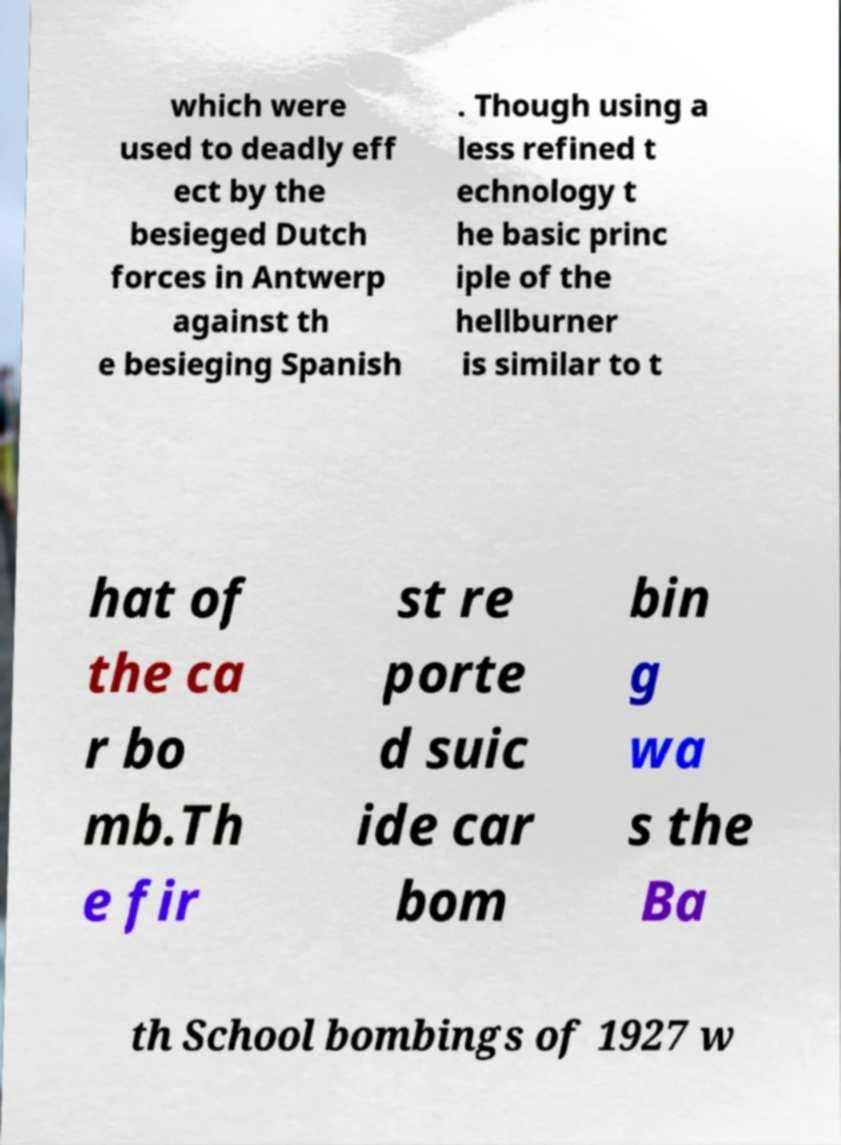Please read and relay the text visible in this image. What does it say? which were used to deadly eff ect by the besieged Dutch forces in Antwerp against th e besieging Spanish . Though using a less refined t echnology t he basic princ iple of the hellburner is similar to t hat of the ca r bo mb.Th e fir st re porte d suic ide car bom bin g wa s the Ba th School bombings of 1927 w 